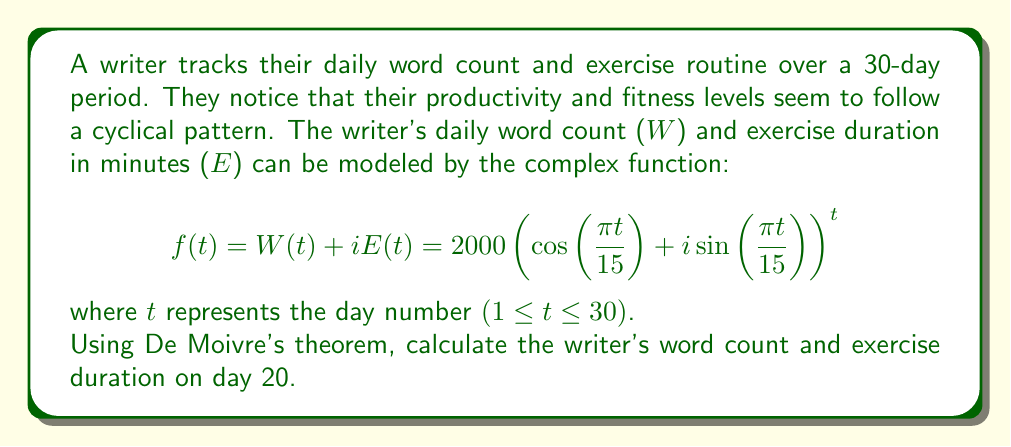What is the answer to this math problem? To solve this problem, we'll use De Moivre's theorem and follow these steps:

1) De Moivre's theorem states that for any real number x and integer n:

   $(\cos(x) + i\sin(x))^n = \cos(nx) + i\sin(nx)$

2) In our case, $x = \frac{\pi t}{15}$ and $n = t$. Let's substitute $t = 20$:

   $f(20) = 2000(\cos(\frac{\pi \cdot 20}{15}) + i\sin(\frac{\pi \cdot 20}{15}))^{20}$

3) Simplify the argument inside the parentheses:

   $f(20) = 2000(\cos(\frac{4\pi}{3}) + i\sin(\frac{4\pi}{3}))^{20}$

4) Apply De Moivre's theorem:

   $f(20) = 2000(\cos(\frac{80\pi}{3}) + i\sin(\frac{80\pi}{3}))$

5) Simplify the argument:

   $\frac{80\pi}{3} = 26\pi + \frac{2\pi}{3} = \frac{2\pi}{3}$ (since the cosine and sine functions have a period of $2\pi$)

   $f(20) = 2000(\cos(\frac{2\pi}{3}) + i\sin(\frac{2\pi}{3}))$

6) Calculate the cosine and sine values:

   $\cos(\frac{2\pi}{3}) = -\frac{1}{2}$
   $\sin(\frac{2\pi}{3}) = \frac{\sqrt{3}}{2}$

7) Substitute these values:

   $f(20) = 2000(-\frac{1}{2} + i\frac{\sqrt{3}}{2})$

8) Separate the real and imaginary parts:

   $f(20) = -1000 + i1000\sqrt{3}$

The real part represents the word count, and the imaginary part represents the exercise duration.

Word count on day 20: $W(20) = -1000$ words
Exercise duration on day 20: $E(20) = 1000\sqrt{3} \approx 1732$ minutes
Answer: On day 20, the writer's word count is -1000 words (indicating a 1000-word reduction from their baseline), and their exercise duration is approximately 1732 minutes. 